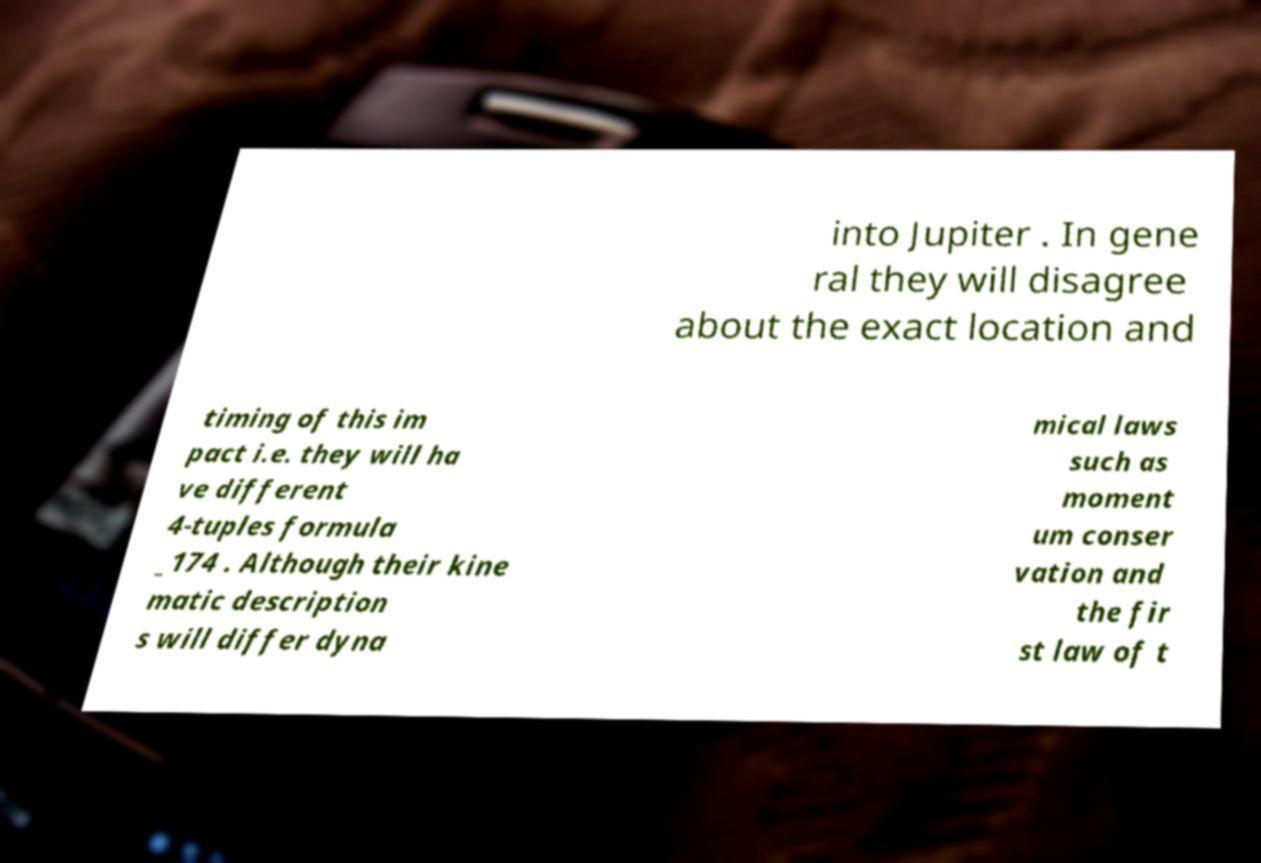Please identify and transcribe the text found in this image. into Jupiter . In gene ral they will disagree about the exact location and timing of this im pact i.e. they will ha ve different 4-tuples formula _174 . Although their kine matic description s will differ dyna mical laws such as moment um conser vation and the fir st law of t 